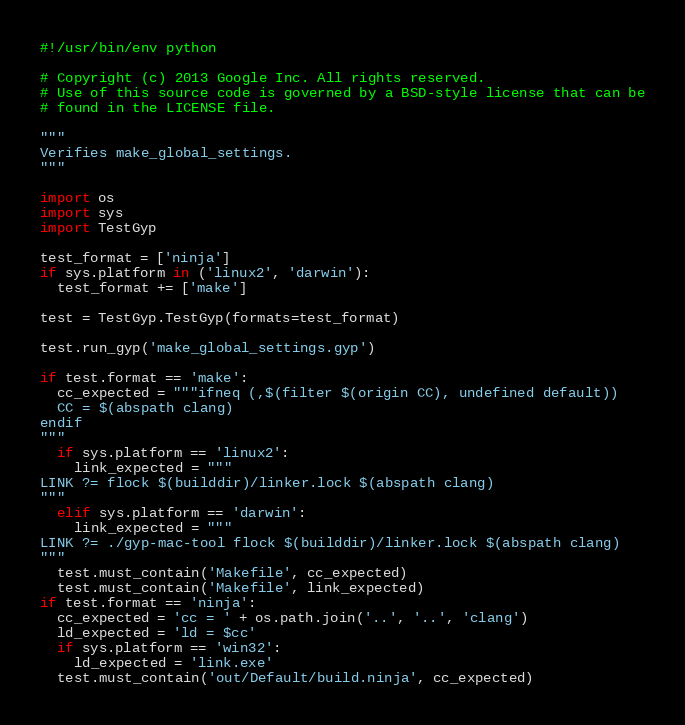<code> <loc_0><loc_0><loc_500><loc_500><_Python_>#!/usr/bin/env python

# Copyright (c) 2013 Google Inc. All rights reserved.
# Use of this source code is governed by a BSD-style license that can be
# found in the LICENSE file.

"""
Verifies make_global_settings.
"""

import os
import sys
import TestGyp

test_format = ['ninja']
if sys.platform in ('linux2', 'darwin'):
  test_format += ['make']

test = TestGyp.TestGyp(formats=test_format)

test.run_gyp('make_global_settings.gyp')

if test.format == 'make':
  cc_expected = """ifneq (,$(filter $(origin CC), undefined default))
  CC = $(abspath clang)
endif
"""
  if sys.platform == 'linux2':
    link_expected = """
LINK ?= flock $(builddir)/linker.lock $(abspath clang)
"""
  elif sys.platform == 'darwin':
    link_expected = """
LINK ?= ./gyp-mac-tool flock $(builddir)/linker.lock $(abspath clang)
"""
  test.must_contain('Makefile', cc_expected)
  test.must_contain('Makefile', link_expected)
if test.format == 'ninja':
  cc_expected = 'cc = ' + os.path.join('..', '..', 'clang')
  ld_expected = 'ld = $cc'
  if sys.platform == 'win32':
    ld_expected = 'link.exe'
  test.must_contain('out/Default/build.ninja', cc_expected)</code> 